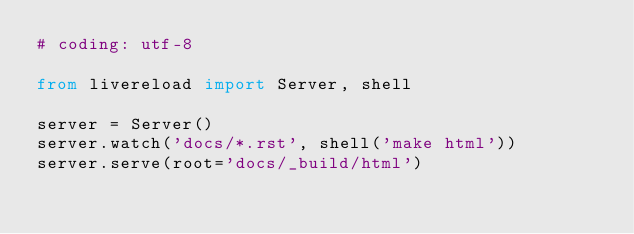<code> <loc_0><loc_0><loc_500><loc_500><_Python_># coding: utf-8

from livereload import Server, shell

server = Server()
server.watch('docs/*.rst', shell('make html'))
server.serve(root='docs/_build/html')
</code> 